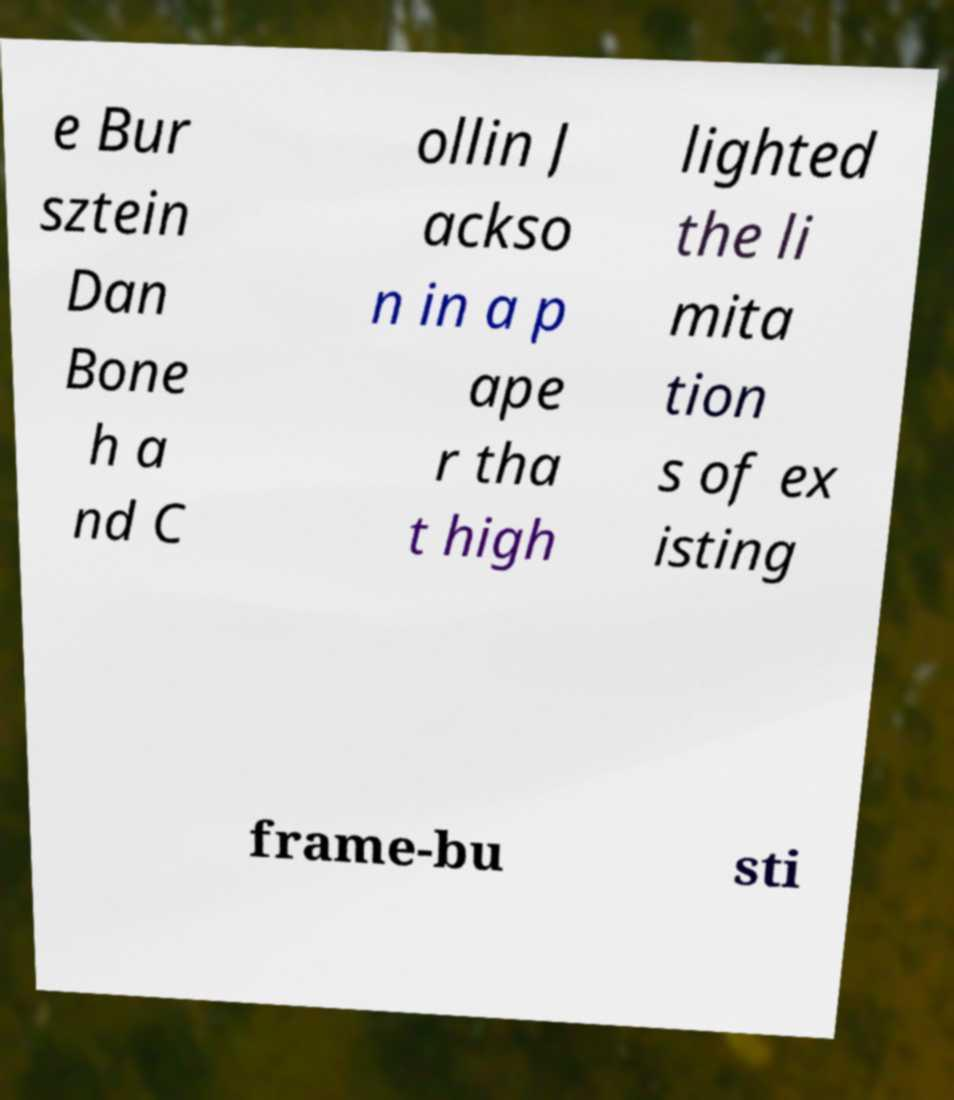Can you accurately transcribe the text from the provided image for me? e Bur sztein Dan Bone h a nd C ollin J ackso n in a p ape r tha t high lighted the li mita tion s of ex isting frame-bu sti 